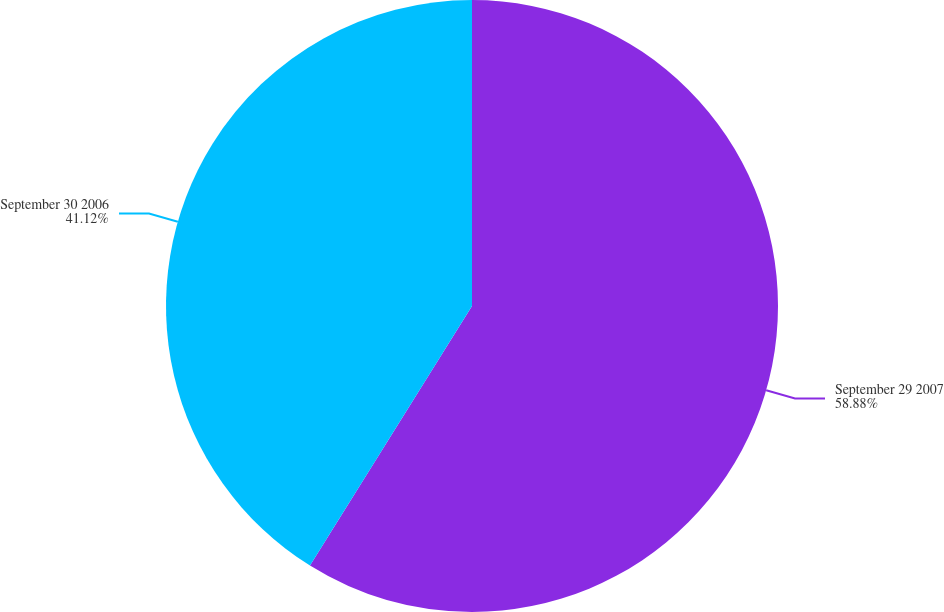<chart> <loc_0><loc_0><loc_500><loc_500><pie_chart><fcel>September 29 2007<fcel>September 30 2006<nl><fcel>58.88%<fcel>41.12%<nl></chart> 